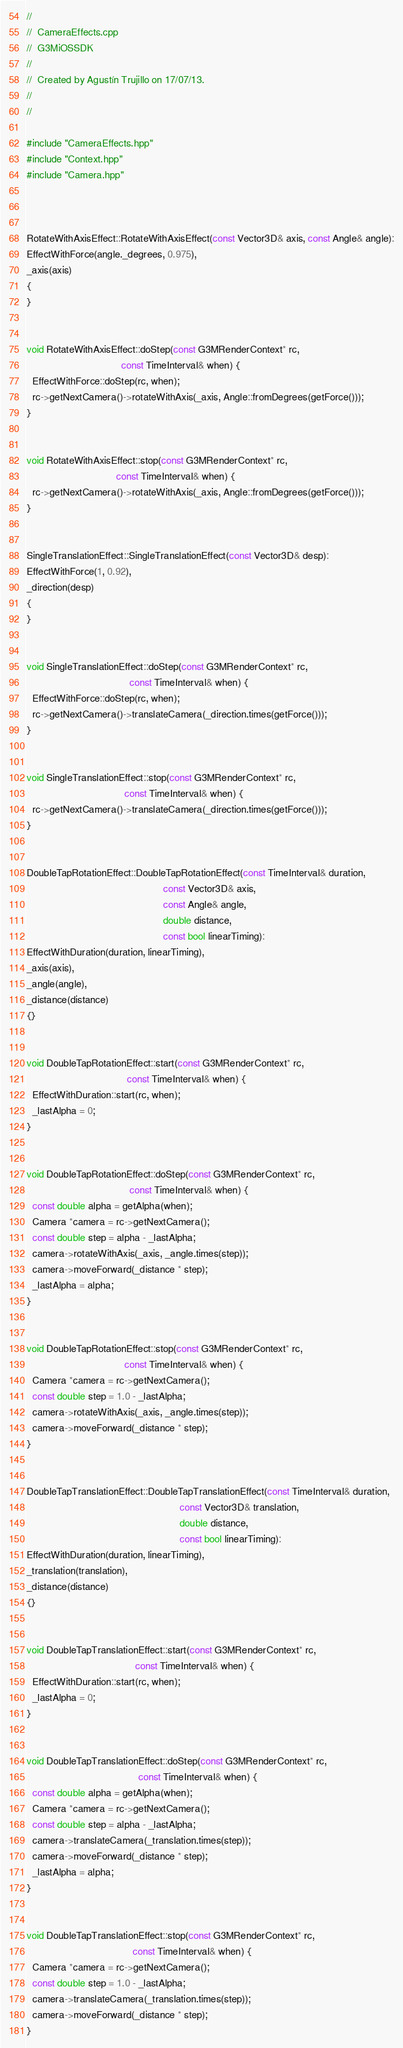<code> <loc_0><loc_0><loc_500><loc_500><_C++_>//
//  CameraEffects.cpp
//  G3MiOSSDK
//
//  Created by Agustín Trujillo on 17/07/13.
//
//

#include "CameraEffects.hpp"
#include "Context.hpp"
#include "Camera.hpp"



RotateWithAxisEffect::RotateWithAxisEffect(const Vector3D& axis, const Angle& angle):
EffectWithForce(angle._degrees, 0.975),
_axis(axis)
{
}


void RotateWithAxisEffect::doStep(const G3MRenderContext* rc,
                                  const TimeInterval& when) {
  EffectWithForce::doStep(rc, when);
  rc->getNextCamera()->rotateWithAxis(_axis, Angle::fromDegrees(getForce()));
}


void RotateWithAxisEffect::stop(const G3MRenderContext* rc,
                                const TimeInterval& when) {
  rc->getNextCamera()->rotateWithAxis(_axis, Angle::fromDegrees(getForce()));
}


SingleTranslationEffect::SingleTranslationEffect(const Vector3D& desp):
EffectWithForce(1, 0.92),
_direction(desp)
{
}


void SingleTranslationEffect::doStep(const G3MRenderContext* rc,
                                     const TimeInterval& when) {
  EffectWithForce::doStep(rc, when);
  rc->getNextCamera()->translateCamera(_direction.times(getForce()));
}


void SingleTranslationEffect::stop(const G3MRenderContext* rc,
                                   const TimeInterval& when) {
  rc->getNextCamera()->translateCamera(_direction.times(getForce()));
}


DoubleTapRotationEffect::DoubleTapRotationEffect(const TimeInterval& duration,
                                                 const Vector3D& axis,
                                                 const Angle& angle,
                                                 double distance,
                                                 const bool linearTiming):
EffectWithDuration(duration, linearTiming),
_axis(axis),
_angle(angle),
_distance(distance)
{}


void DoubleTapRotationEffect::start(const G3MRenderContext* rc,
                                    const TimeInterval& when) {
  EffectWithDuration::start(rc, when);
  _lastAlpha = 0;
}


void DoubleTapRotationEffect::doStep(const G3MRenderContext* rc,
                                     const TimeInterval& when) {
  const double alpha = getAlpha(when);
  Camera *camera = rc->getNextCamera();
  const double step = alpha - _lastAlpha;
  camera->rotateWithAxis(_axis, _angle.times(step));
  camera->moveForward(_distance * step);
  _lastAlpha = alpha;
}


void DoubleTapRotationEffect::stop(const G3MRenderContext* rc,
                                   const TimeInterval& when) {
  Camera *camera = rc->getNextCamera();
  const double step = 1.0 - _lastAlpha;
  camera->rotateWithAxis(_axis, _angle.times(step));
  camera->moveForward(_distance * step);
}


DoubleTapTranslationEffect::DoubleTapTranslationEffect(const TimeInterval& duration,
                                                       const Vector3D& translation,
                                                       double distance,
                                                       const bool linearTiming):
EffectWithDuration(duration, linearTiming),
_translation(translation),
_distance(distance)
{}


void DoubleTapTranslationEffect::start(const G3MRenderContext* rc,
                                       const TimeInterval& when) {
  EffectWithDuration::start(rc, when);
  _lastAlpha = 0;
}


void DoubleTapTranslationEffect::doStep(const G3MRenderContext* rc,
                                        const TimeInterval& when) {
  const double alpha = getAlpha(when);
  Camera *camera = rc->getNextCamera();
  const double step = alpha - _lastAlpha;
  camera->translateCamera(_translation.times(step));
  camera->moveForward(_distance * step);
  _lastAlpha = alpha;
}


void DoubleTapTranslationEffect::stop(const G3MRenderContext* rc,
                                      const TimeInterval& when) {
  Camera *camera = rc->getNextCamera();
  const double step = 1.0 - _lastAlpha;
  camera->translateCamera(_translation.times(step));
  camera->moveForward(_distance * step);
}


</code> 